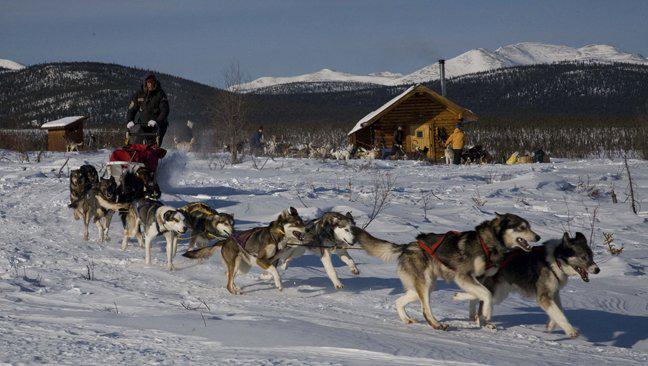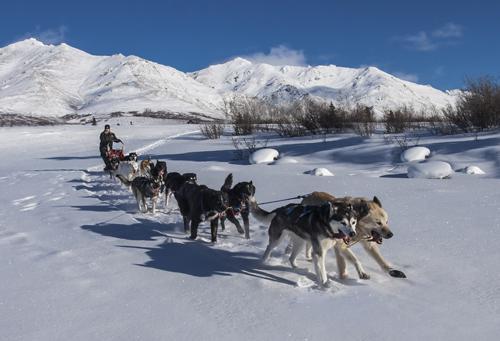The first image is the image on the left, the second image is the image on the right. Examine the images to the left and right. Is the description "A building with a snow-covered peaked roof is in the background of an image with at least one sled dog team racing across the snow." accurate? Answer yes or no. Yes. The first image is the image on the left, the second image is the image on the right. Examine the images to the left and right. Is the description "A dogsled is traveling slightly to the right in at least one of the images." accurate? Answer yes or no. Yes. 